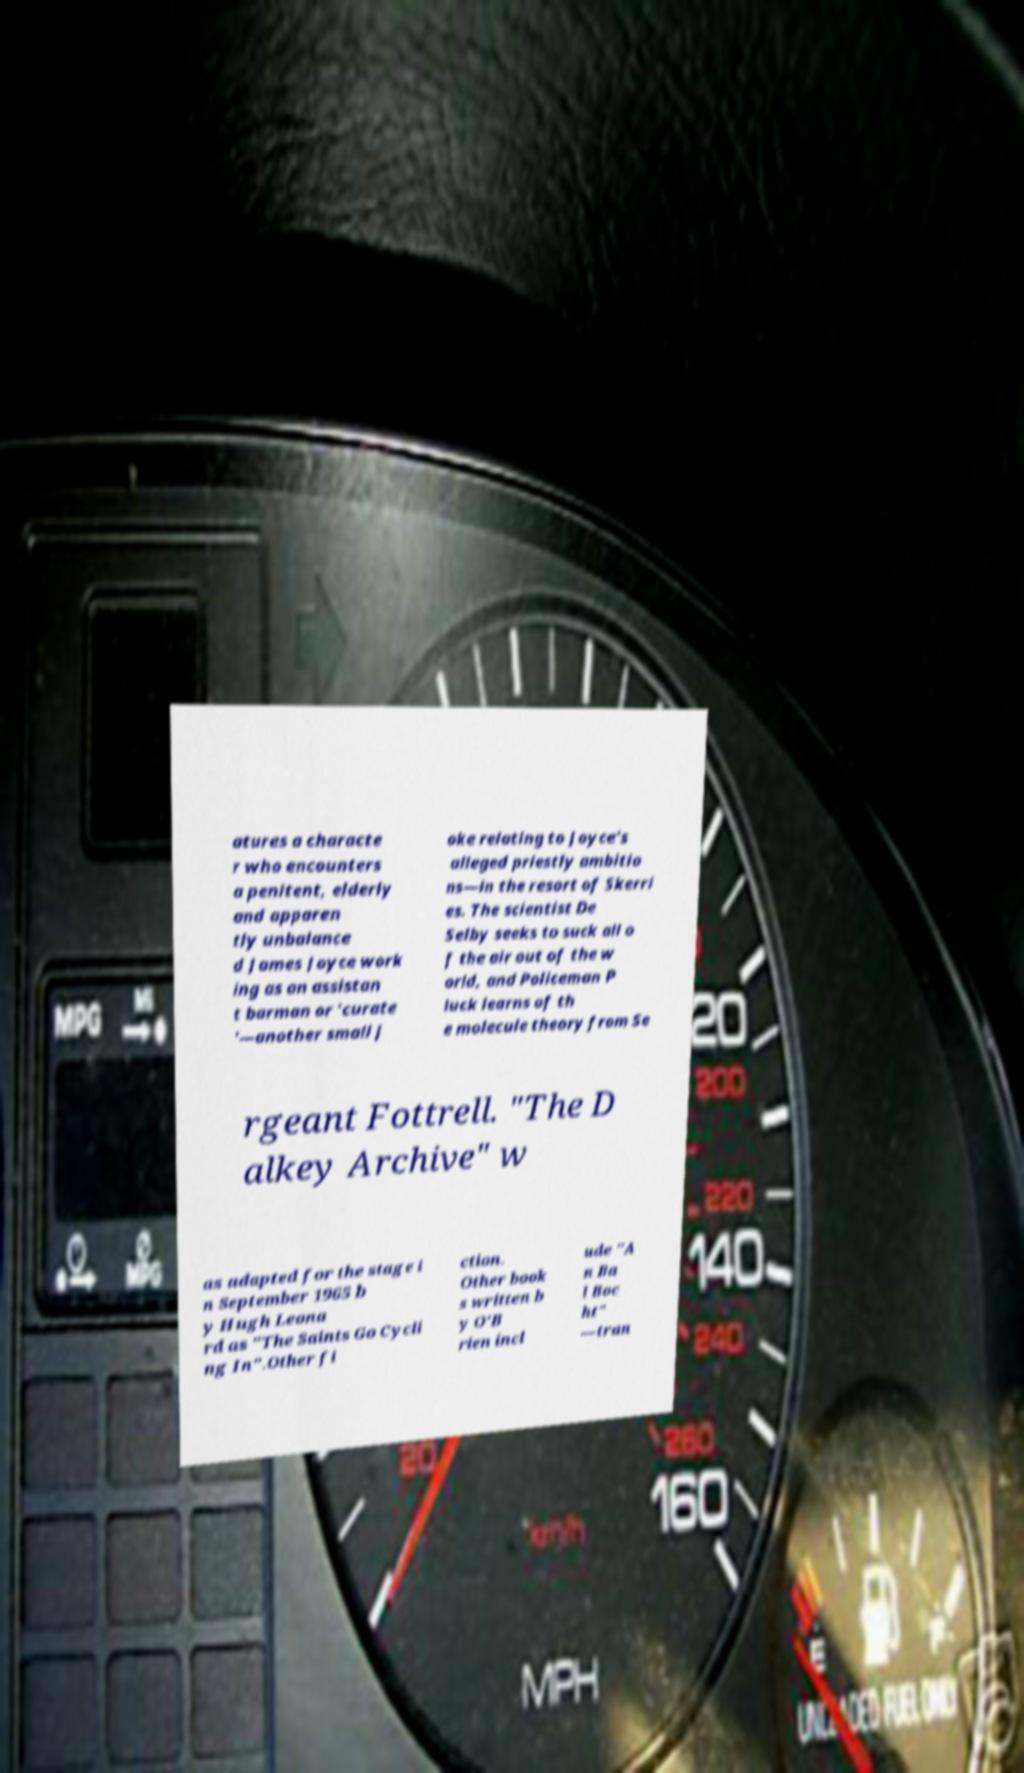I need the written content from this picture converted into text. Can you do that? atures a characte r who encounters a penitent, elderly and apparen tly unbalance d James Joyce work ing as an assistan t barman or 'curate '—another small j oke relating to Joyce's alleged priestly ambitio ns—in the resort of Skerri es. The scientist De Selby seeks to suck all o f the air out of the w orld, and Policeman P luck learns of th e molecule theory from Se rgeant Fottrell. "The D alkey Archive" w as adapted for the stage i n September 1965 b y Hugh Leona rd as "The Saints Go Cycli ng In".Other fi ction. Other book s written b y O'B rien incl ude "A n Ba l Boc ht" —tran 